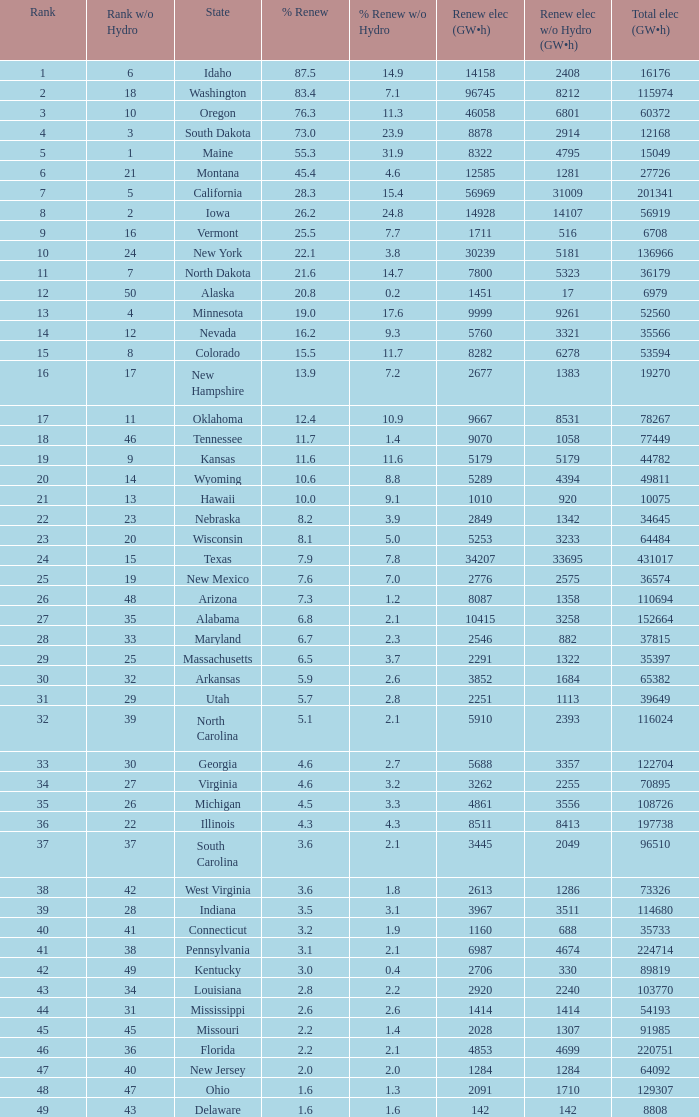In south dakota, what proportion of the renewable electricity excludes hydrogen power? 23.9. 